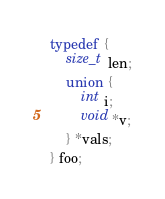Convert code to text. <code><loc_0><loc_0><loc_500><loc_500><_C_>typedef {
	size_t len;
	union {
		int i;
		void *v;
	} *vals;
} foo;
</code> 